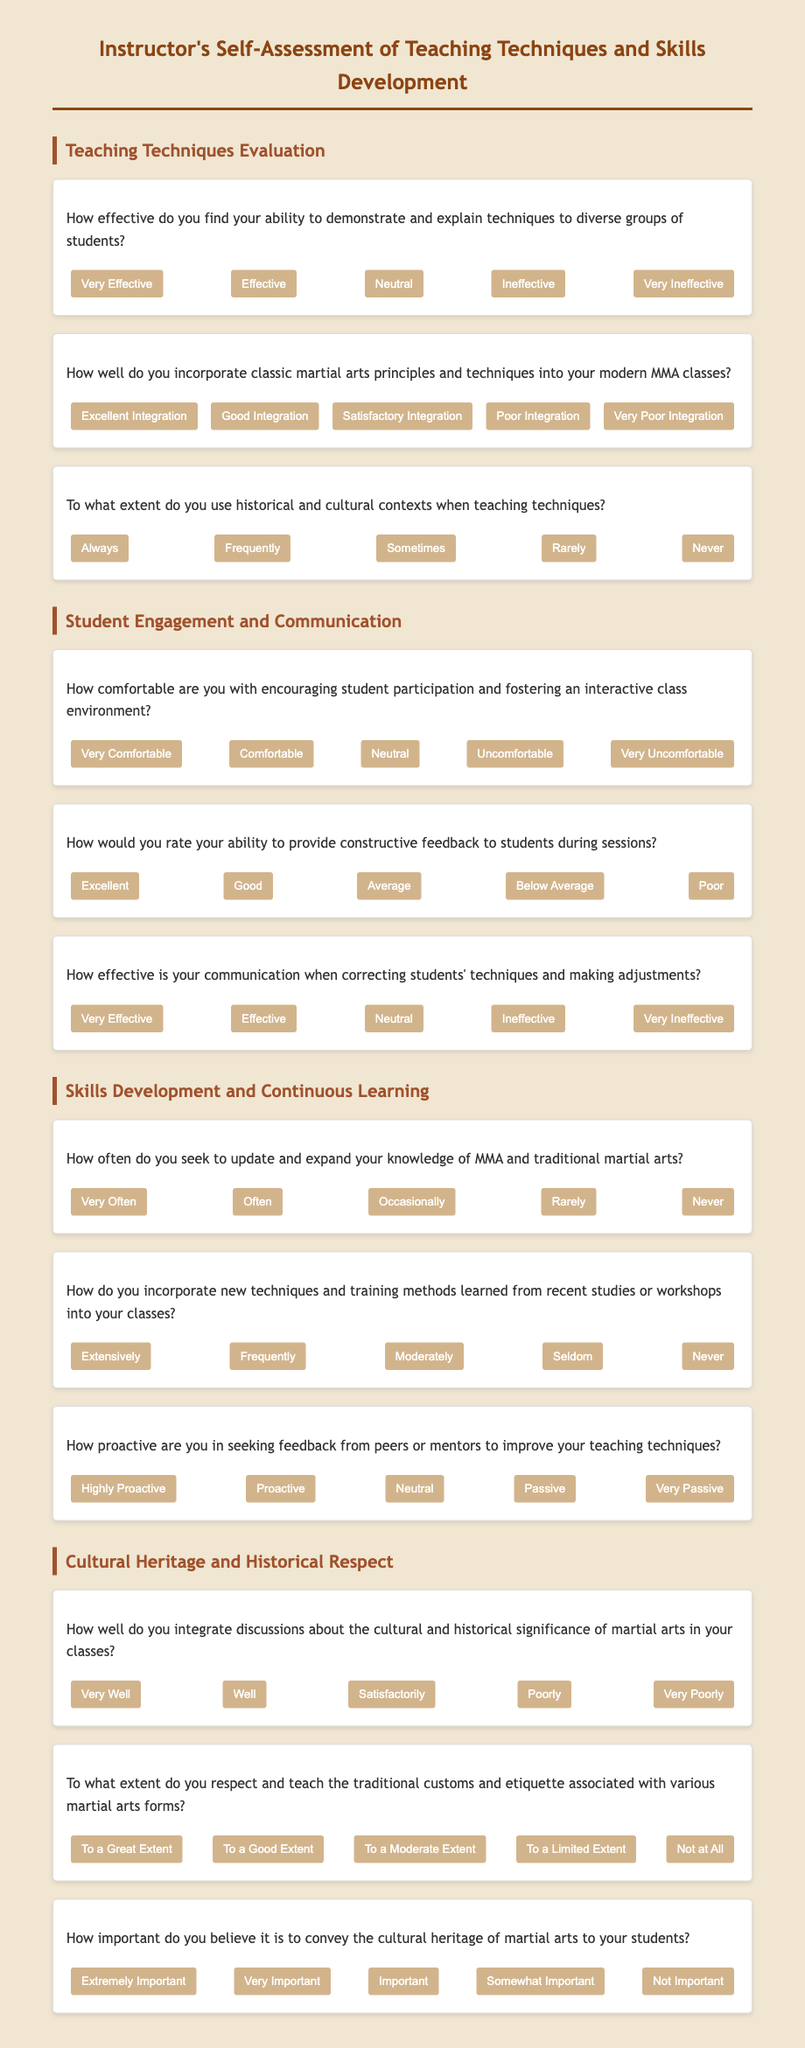How many sections are in the questionnaire? The questionnaire is divided into four main sections: Teaching Techniques Evaluation, Student Engagement and Communication, Skills Development and Continuous Learning, and Cultural Heritage and Historical Respect.
Answer: 4 What is the first question under Student Engagement and Communication? The first question under this section asks about the instructor's comfort level in encouraging student participation and fostering an interactive class environment.
Answer: How comfortable are you with encouraging student participation and fostering an interactive class environment? What is the most favorable option for describing integration of classic martial arts principles into modern classes? The document provides various options ranging from 'Excellent Integration' to 'Very Poor Integration'; the most favorable option is 'Excellent Integration'.
Answer: Excellent Integration How is the questionnaire structured visually? The document uses a clear structure with headings, divided questions, and styled buttons for responses, making it easy to navigate through different sections of the assessment.
Answer: Clear structure What is the last question in the questionnaire about? The last question addresses the importance of conveying cultural heritage to students, highlighting the instructor's perspective on cultural significance in martial arts education.
Answer: How important do you believe it is to convey the cultural heritage of martial arts to your students? 